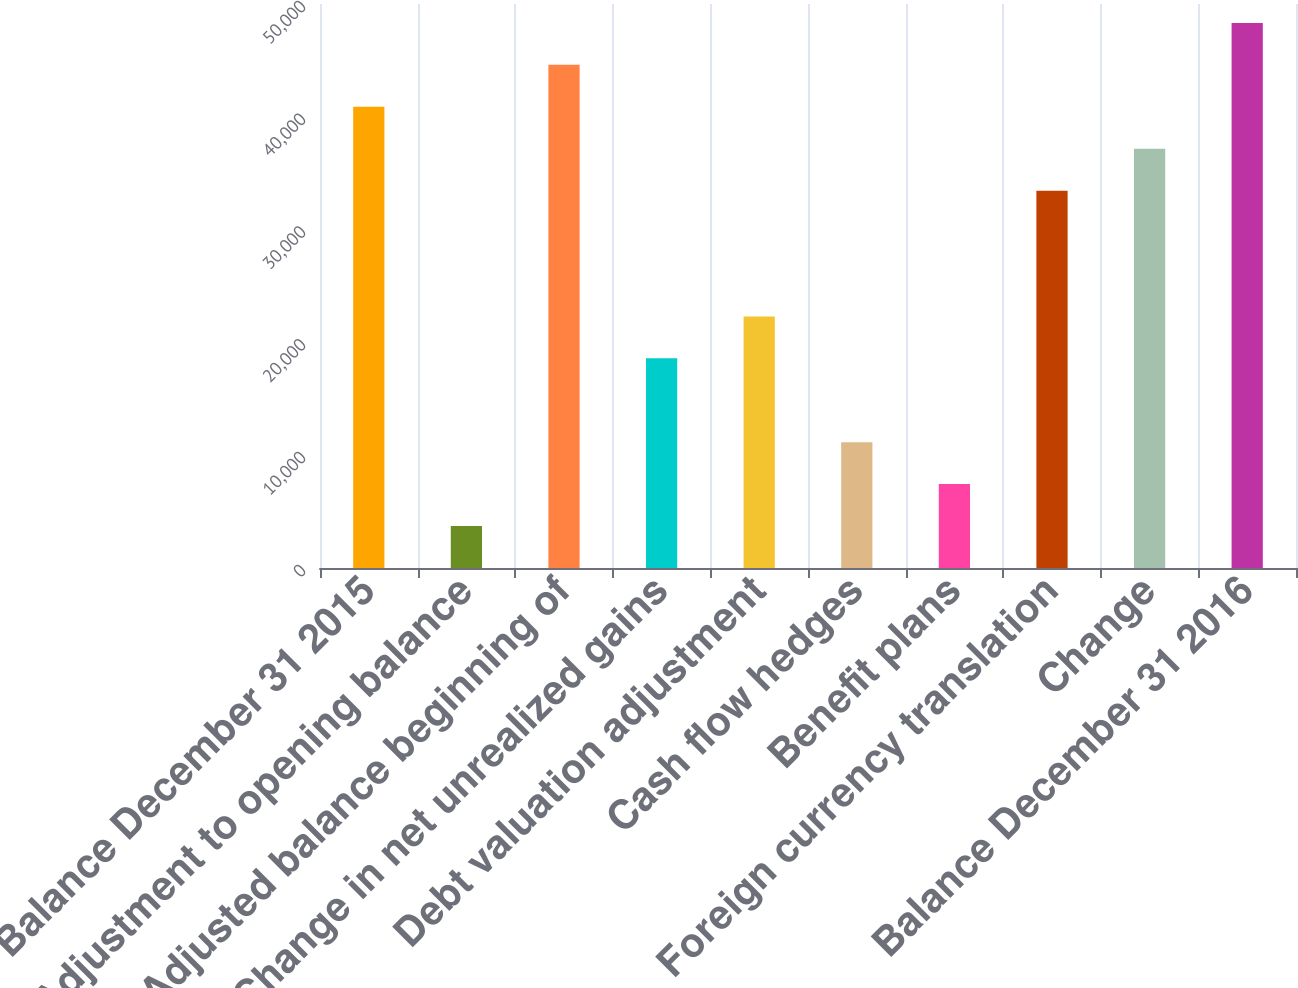Convert chart to OTSL. <chart><loc_0><loc_0><loc_500><loc_500><bar_chart><fcel>Balance December 31 2015<fcel>Adjustment to opening balance<fcel>Adjusted balance beginning of<fcel>Change in net unrealized gains<fcel>Debt valuation adjustment<fcel>Cash flow hedges<fcel>Benefit plans<fcel>Foreign currency translation<fcel>Change<fcel>Balance December 31 2016<nl><fcel>40886.7<fcel>3719.7<fcel>44603.4<fcel>18586.5<fcel>22303.2<fcel>11153.1<fcel>7436.4<fcel>33453.3<fcel>37170<fcel>48320.1<nl></chart> 